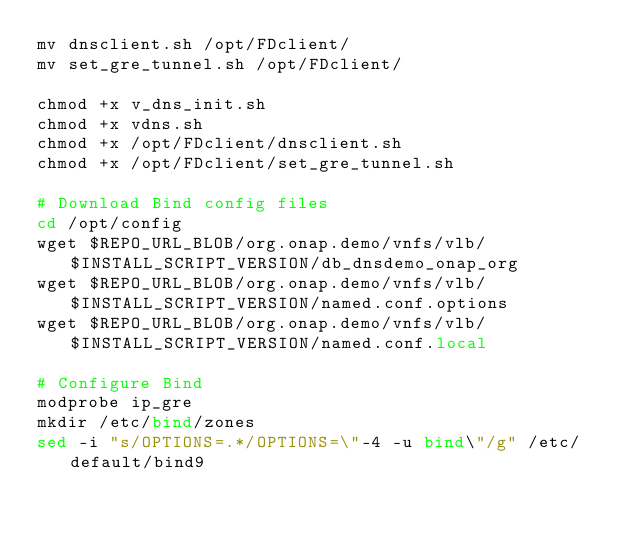Convert code to text. <code><loc_0><loc_0><loc_500><loc_500><_Bash_>mv dnsclient.sh /opt/FDclient/
mv set_gre_tunnel.sh /opt/FDclient/

chmod +x v_dns_init.sh
chmod +x vdns.sh
chmod +x /opt/FDclient/dnsclient.sh
chmod +x /opt/FDclient/set_gre_tunnel.sh

# Download Bind config files
cd /opt/config
wget $REPO_URL_BLOB/org.onap.demo/vnfs/vlb/$INSTALL_SCRIPT_VERSION/db_dnsdemo_onap_org
wget $REPO_URL_BLOB/org.onap.demo/vnfs/vlb/$INSTALL_SCRIPT_VERSION/named.conf.options
wget $REPO_URL_BLOB/org.onap.demo/vnfs/vlb/$INSTALL_SCRIPT_VERSION/named.conf.local

# Configure Bind
modprobe ip_gre
mkdir /etc/bind/zones
sed -i "s/OPTIONS=.*/OPTIONS=\"-4 -u bind\"/g" /etc/default/bind9</code> 